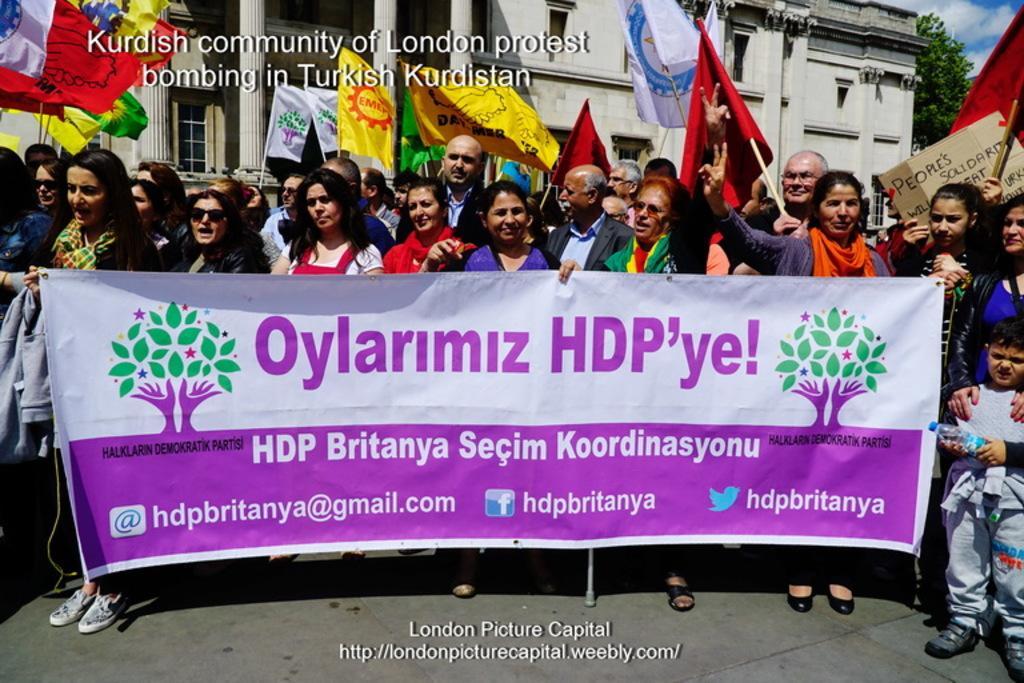In one or two sentences, can you explain what this image depicts? In this image, we can see a group of people holding a banner and some flags In front of the building. 